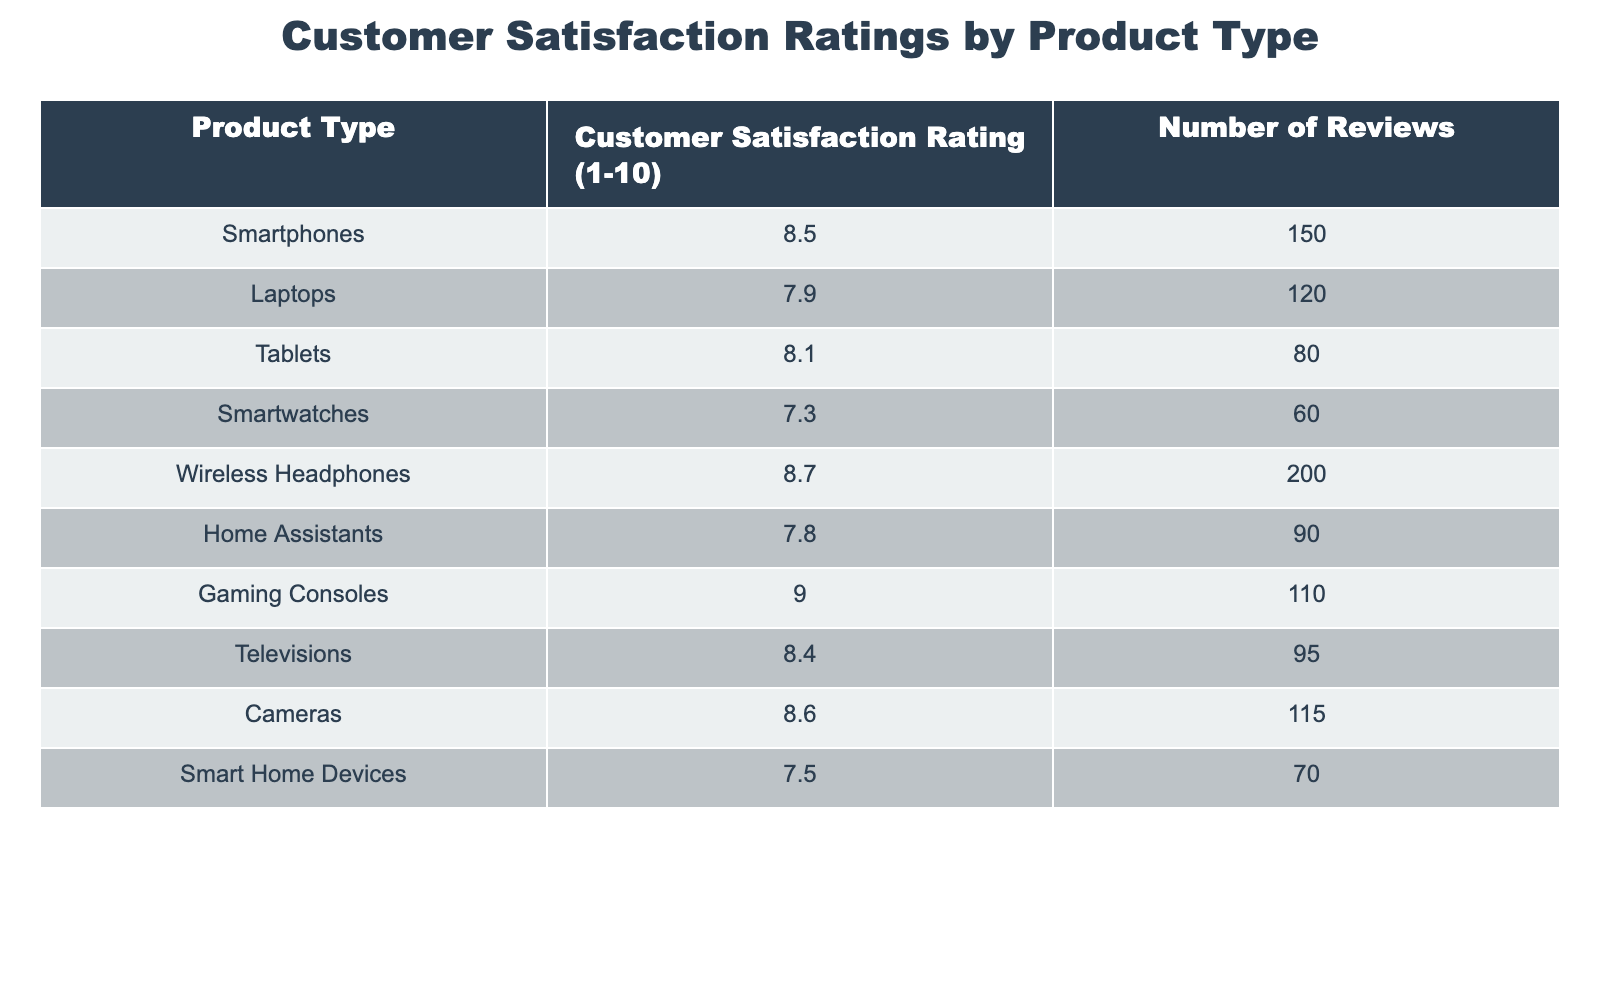What is the highest customer satisfaction rating? The highest customer satisfaction rating in the table is found by comparing all listed ratings. The rating for Gaming Consoles is 9.0, which is higher than any other product type.
Answer: 9.0 Which product type has the lowest customer satisfaction rating? By examining all customer satisfaction ratings in the table, Smartwatches have the lowest rating at 7.3.
Answer: 7.3 What is the total number of reviews for Smartphones and Tablets? The total reviews for Smartphones is 150 and for Tablets it's 80. Adding these gives 150 + 80 = 230.
Answer: 230 Which product type has the highest number of reviews? To find the product with the highest reviews, we examine the "Number of Reviews" column. Wireless Headphones has 200 reviews, which is the highest.
Answer: Wireless Headphones What is the average customer satisfaction rating across all product types? First, sum the satisfaction ratings: 8.5 + 7.9 + 8.1 + 7.3 + 8.7 + 7.8 + 9.0 + 8.4 + 8.6 + 7.5 = 79.4. There are 10 product types, so the average is 79.4 / 10 = 7.94.
Answer: 7.94 Is the customer satisfaction rating for Laptops higher than that for Smart Home Devices? Comparing the ratings, Laptops have a rating of 7.9 while Smart Home Devices have a rating of 7.5. Since 7.9 is greater than 7.5, the statement is true.
Answer: Yes What is the difference in customer satisfaction ratings between Wireless Headphones and Smartwatches? Wireless Headphones have a rating of 8.7, and Smartwatches have a rating of 7.3. The difference is calculated as 8.7 - 7.3 = 1.4.
Answer: 1.4 If you combine the satisfaction ratings of Tablets and Home Assistants, what is the total? Tablets have a rating of 8.1 and Home Assistants have a rating of 7.8. Adding these two ratings gives 8.1 + 7.8 = 15.9.
Answer: 15.9 How many product types have a satisfaction rating above 8.0? Review the table for ratings above 8.0: Smartphones (8.5), Tablets (8.1), Wireless Headphones (8.7), Gaming Consoles (9.0), Televisions (8.4), Cameras (8.6). There are 6 such products.
Answer: 6 Which two product types have customer satisfaction ratings that average above 8.0? Reviewing product pairs, Wireless Headphones (8.7) and Gaming Consoles (9.0) average (8.7 + 9.0) / 2 = 8.85, which is greater than 8.0. Also Smartphones (8.5) and Cameras (8.6) average (8.5 + 8.6) / 2 = 8.55. Both pairs meet the criteria.
Answer: Wireless Headphones & Gaming Consoles / Smartphones & Cameras 